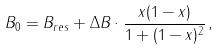Convert formula to latex. <formula><loc_0><loc_0><loc_500><loc_500>B _ { 0 } = B _ { r e s } + \Delta B \cdot \frac { x ( 1 - x ) } { 1 + ( 1 - x ) ^ { 2 } } \, ,</formula> 